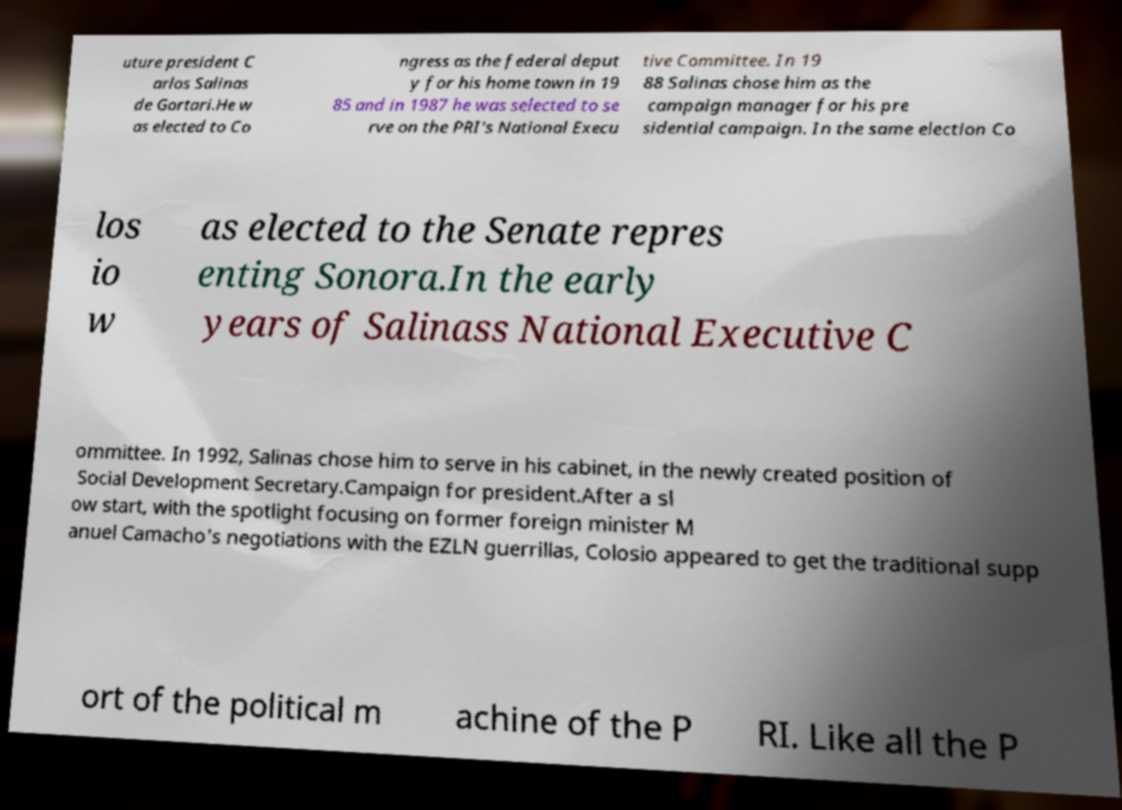What messages or text are displayed in this image? I need them in a readable, typed format. uture president C arlos Salinas de Gortari.He w as elected to Co ngress as the federal deput y for his home town in 19 85 and in 1987 he was selected to se rve on the PRI's National Execu tive Committee. In 19 88 Salinas chose him as the campaign manager for his pre sidential campaign. In the same election Co los io w as elected to the Senate repres enting Sonora.In the early years of Salinass National Executive C ommittee. In 1992, Salinas chose him to serve in his cabinet, in the newly created position of Social Development Secretary.Campaign for president.After a sl ow start, with the spotlight focusing on former foreign minister M anuel Camacho's negotiations with the EZLN guerrillas, Colosio appeared to get the traditional supp ort of the political m achine of the P RI. Like all the P 